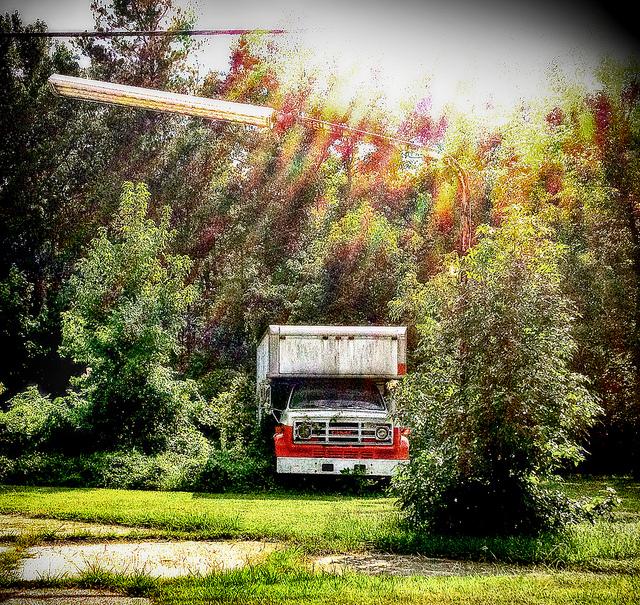What was the brand of the vehicle?
Short answer required. U haul. Is the truck neat or messy?
Keep it brief. Messy. What activity is this vehicle typically used for?
Give a very brief answer. Moving. 